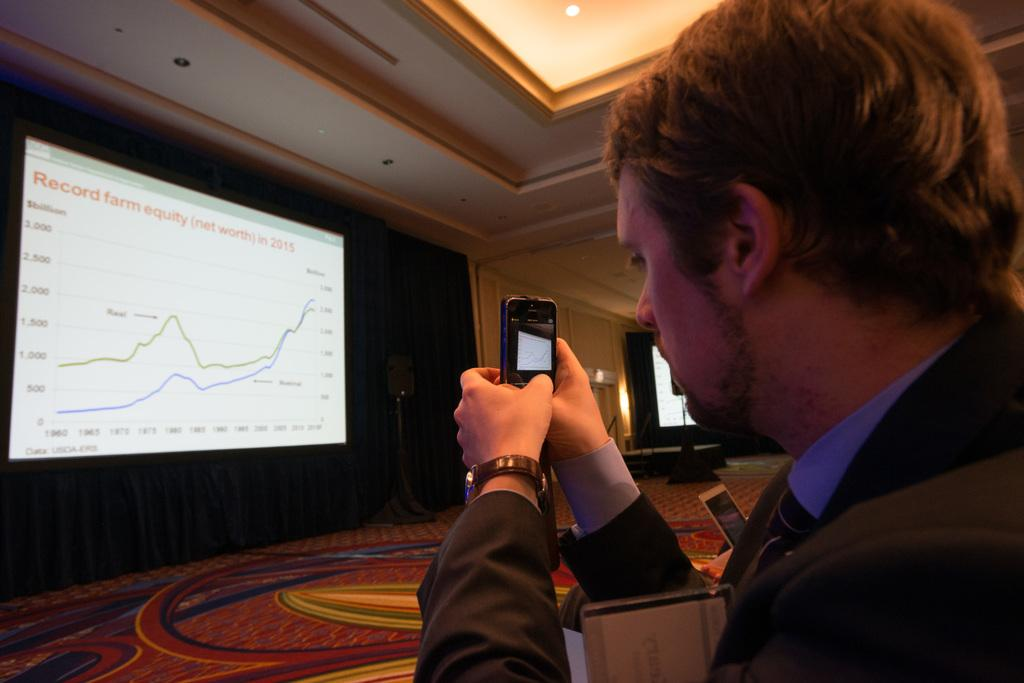What can be seen in the image? There is a person in the image. What is the person wearing? The person is wearing a blazer. What is the person holding? The person is holding a mobile. What is in front of the person? There is a screen in front of the person. What is the background of the screen? The screen is in front of a black wall. What can be seen at the top of the image? There are lights visible at the top of the image. Where is the patch of grass located in the image? There is no patch of grass present in the image. What type of market can be seen in the background of the image? There is no market visible in the image; it features a person, a screen, and a black wall. 